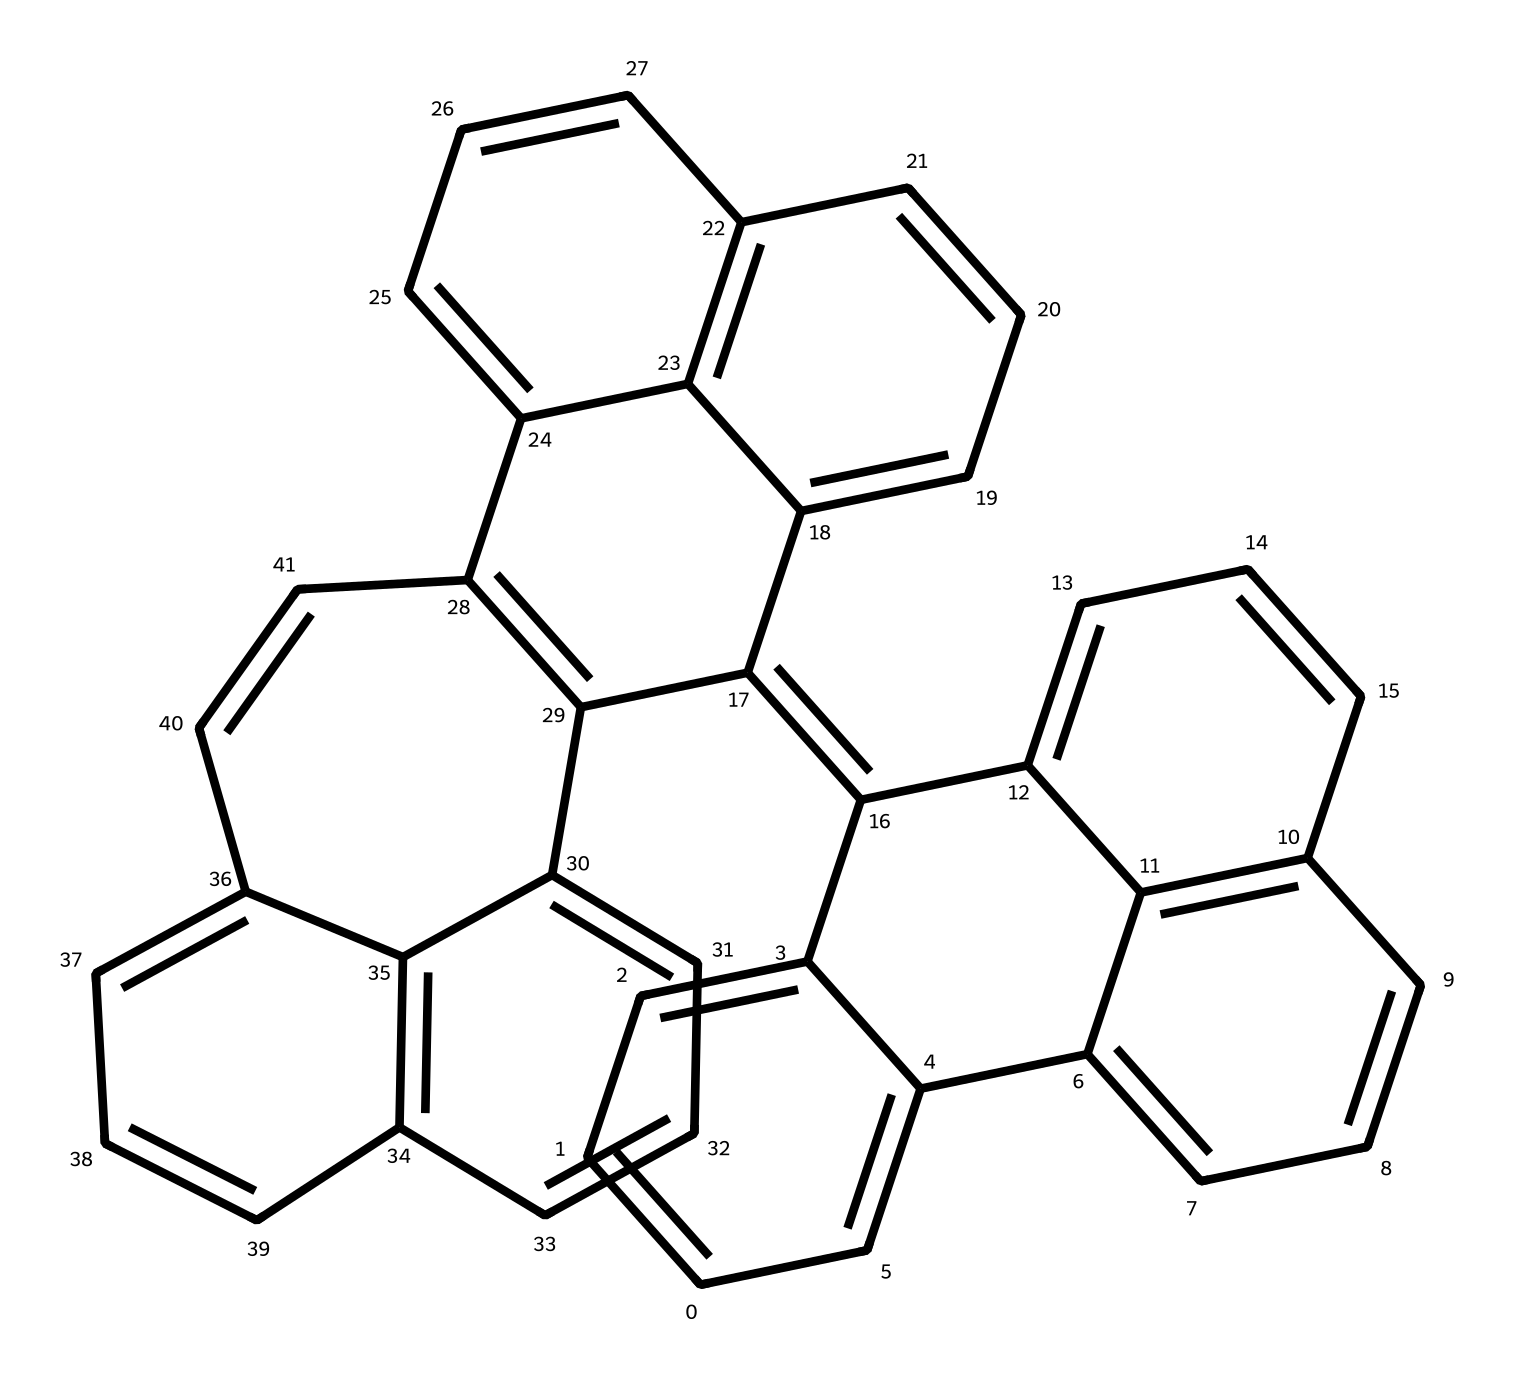What is the total number of carbon atoms in this structure? By analyzing the SMILES representation, we can observe that each "C" corresponds to a carbon atom. Counting all the carbon atoms in the SMILES yields a total of 24 carbon atoms.
Answer: 24 How many double bonds are present in the chemical structure? In the SMILES, double bonds are indicated by the "=" sign. Counting the "=" signs within the structure gives a total of 12 double bonds.
Answer: 12 What is the predominant application of graphene quantum dots? Graphene quantum dots are primarily applied in bioimaging due to their unique optical properties and biocompatibility, making them ideal for imaging applications in biological systems.
Answer: bioimaging What type of light emission can be expected from the molecular arrangement? Given the structure of quantum dots, they typically exhibit photoluminescence, which refers to the emission of light when they are excited by a light source.
Answer: photoluminescence Which structural characteristic contributes to the environmental friendliness of these quantum dots? The arrangement of carbon atoms with minimal use of toxic elements directly influences the eco-friendliness of graphene quantum dots, making them less harmful in comparison to traditional quantum dots that may contain heavy metals.
Answer: carbon arrangement 